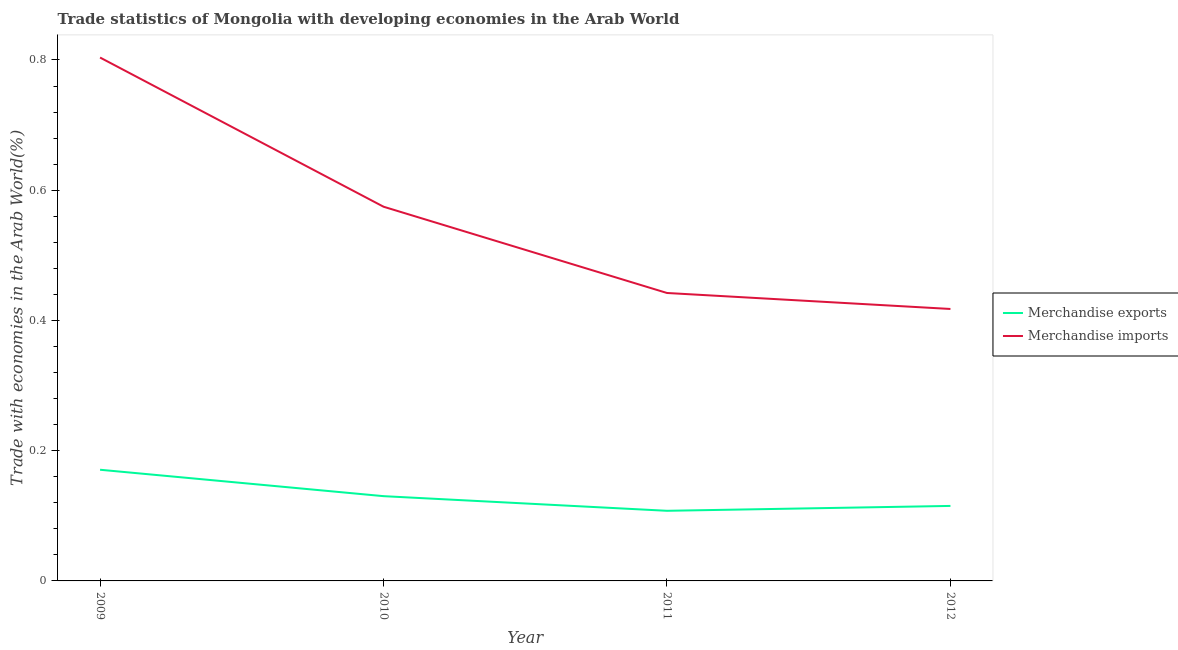Is the number of lines equal to the number of legend labels?
Your answer should be compact. Yes. What is the merchandise imports in 2009?
Your answer should be very brief. 0.8. Across all years, what is the maximum merchandise exports?
Give a very brief answer. 0.17. Across all years, what is the minimum merchandise imports?
Offer a terse response. 0.42. In which year was the merchandise exports maximum?
Your answer should be compact. 2009. In which year was the merchandise exports minimum?
Give a very brief answer. 2011. What is the total merchandise imports in the graph?
Your answer should be very brief. 2.24. What is the difference between the merchandise exports in 2009 and that in 2012?
Give a very brief answer. 0.06. What is the difference between the merchandise exports in 2012 and the merchandise imports in 2011?
Provide a succinct answer. -0.33. What is the average merchandise exports per year?
Your answer should be compact. 0.13. In the year 2011, what is the difference between the merchandise exports and merchandise imports?
Your response must be concise. -0.33. What is the ratio of the merchandise imports in 2011 to that in 2012?
Offer a very short reply. 1.06. Is the merchandise exports in 2011 less than that in 2012?
Offer a very short reply. Yes. Is the difference between the merchandise imports in 2009 and 2011 greater than the difference between the merchandise exports in 2009 and 2011?
Your response must be concise. Yes. What is the difference between the highest and the second highest merchandise imports?
Offer a very short reply. 0.23. What is the difference between the highest and the lowest merchandise imports?
Provide a succinct answer. 0.39. Is the sum of the merchandise exports in 2009 and 2010 greater than the maximum merchandise imports across all years?
Offer a terse response. No. Does the merchandise exports monotonically increase over the years?
Provide a short and direct response. No. How many years are there in the graph?
Keep it short and to the point. 4. Are the values on the major ticks of Y-axis written in scientific E-notation?
Provide a succinct answer. No. Does the graph contain any zero values?
Offer a very short reply. No. Does the graph contain grids?
Give a very brief answer. No. How many legend labels are there?
Make the answer very short. 2. What is the title of the graph?
Your answer should be compact. Trade statistics of Mongolia with developing economies in the Arab World. Does "Study and work" appear as one of the legend labels in the graph?
Offer a terse response. No. What is the label or title of the Y-axis?
Your answer should be very brief. Trade with economies in the Arab World(%). What is the Trade with economies in the Arab World(%) of Merchandise exports in 2009?
Provide a short and direct response. 0.17. What is the Trade with economies in the Arab World(%) of Merchandise imports in 2009?
Your answer should be very brief. 0.8. What is the Trade with economies in the Arab World(%) of Merchandise exports in 2010?
Ensure brevity in your answer.  0.13. What is the Trade with economies in the Arab World(%) of Merchandise imports in 2010?
Make the answer very short. 0.57. What is the Trade with economies in the Arab World(%) of Merchandise exports in 2011?
Ensure brevity in your answer.  0.11. What is the Trade with economies in the Arab World(%) of Merchandise imports in 2011?
Provide a succinct answer. 0.44. What is the Trade with economies in the Arab World(%) of Merchandise exports in 2012?
Your answer should be compact. 0.12. What is the Trade with economies in the Arab World(%) of Merchandise imports in 2012?
Offer a terse response. 0.42. Across all years, what is the maximum Trade with economies in the Arab World(%) in Merchandise exports?
Offer a very short reply. 0.17. Across all years, what is the maximum Trade with economies in the Arab World(%) in Merchandise imports?
Your answer should be compact. 0.8. Across all years, what is the minimum Trade with economies in the Arab World(%) of Merchandise exports?
Ensure brevity in your answer.  0.11. Across all years, what is the minimum Trade with economies in the Arab World(%) of Merchandise imports?
Provide a succinct answer. 0.42. What is the total Trade with economies in the Arab World(%) of Merchandise exports in the graph?
Offer a very short reply. 0.52. What is the total Trade with economies in the Arab World(%) in Merchandise imports in the graph?
Ensure brevity in your answer.  2.24. What is the difference between the Trade with economies in the Arab World(%) of Merchandise exports in 2009 and that in 2010?
Offer a very short reply. 0.04. What is the difference between the Trade with economies in the Arab World(%) of Merchandise imports in 2009 and that in 2010?
Your answer should be very brief. 0.23. What is the difference between the Trade with economies in the Arab World(%) in Merchandise exports in 2009 and that in 2011?
Provide a short and direct response. 0.06. What is the difference between the Trade with economies in the Arab World(%) of Merchandise imports in 2009 and that in 2011?
Provide a short and direct response. 0.36. What is the difference between the Trade with economies in the Arab World(%) in Merchandise exports in 2009 and that in 2012?
Provide a succinct answer. 0.06. What is the difference between the Trade with economies in the Arab World(%) in Merchandise imports in 2009 and that in 2012?
Offer a terse response. 0.39. What is the difference between the Trade with economies in the Arab World(%) of Merchandise exports in 2010 and that in 2011?
Give a very brief answer. 0.02. What is the difference between the Trade with economies in the Arab World(%) in Merchandise imports in 2010 and that in 2011?
Provide a succinct answer. 0.13. What is the difference between the Trade with economies in the Arab World(%) of Merchandise exports in 2010 and that in 2012?
Your answer should be compact. 0.01. What is the difference between the Trade with economies in the Arab World(%) in Merchandise imports in 2010 and that in 2012?
Offer a very short reply. 0.16. What is the difference between the Trade with economies in the Arab World(%) in Merchandise exports in 2011 and that in 2012?
Provide a succinct answer. -0.01. What is the difference between the Trade with economies in the Arab World(%) of Merchandise imports in 2011 and that in 2012?
Your response must be concise. 0.02. What is the difference between the Trade with economies in the Arab World(%) of Merchandise exports in 2009 and the Trade with economies in the Arab World(%) of Merchandise imports in 2010?
Give a very brief answer. -0.4. What is the difference between the Trade with economies in the Arab World(%) in Merchandise exports in 2009 and the Trade with economies in the Arab World(%) in Merchandise imports in 2011?
Make the answer very short. -0.27. What is the difference between the Trade with economies in the Arab World(%) of Merchandise exports in 2009 and the Trade with economies in the Arab World(%) of Merchandise imports in 2012?
Keep it short and to the point. -0.25. What is the difference between the Trade with economies in the Arab World(%) in Merchandise exports in 2010 and the Trade with economies in the Arab World(%) in Merchandise imports in 2011?
Offer a very short reply. -0.31. What is the difference between the Trade with economies in the Arab World(%) in Merchandise exports in 2010 and the Trade with economies in the Arab World(%) in Merchandise imports in 2012?
Offer a terse response. -0.29. What is the difference between the Trade with economies in the Arab World(%) in Merchandise exports in 2011 and the Trade with economies in the Arab World(%) in Merchandise imports in 2012?
Your response must be concise. -0.31. What is the average Trade with economies in the Arab World(%) of Merchandise exports per year?
Offer a terse response. 0.13. What is the average Trade with economies in the Arab World(%) of Merchandise imports per year?
Your response must be concise. 0.56. In the year 2009, what is the difference between the Trade with economies in the Arab World(%) of Merchandise exports and Trade with economies in the Arab World(%) of Merchandise imports?
Provide a short and direct response. -0.63. In the year 2010, what is the difference between the Trade with economies in the Arab World(%) of Merchandise exports and Trade with economies in the Arab World(%) of Merchandise imports?
Offer a terse response. -0.44. In the year 2011, what is the difference between the Trade with economies in the Arab World(%) of Merchandise exports and Trade with economies in the Arab World(%) of Merchandise imports?
Give a very brief answer. -0.33. In the year 2012, what is the difference between the Trade with economies in the Arab World(%) of Merchandise exports and Trade with economies in the Arab World(%) of Merchandise imports?
Offer a very short reply. -0.3. What is the ratio of the Trade with economies in the Arab World(%) of Merchandise exports in 2009 to that in 2010?
Your response must be concise. 1.31. What is the ratio of the Trade with economies in the Arab World(%) of Merchandise imports in 2009 to that in 2010?
Give a very brief answer. 1.4. What is the ratio of the Trade with economies in the Arab World(%) of Merchandise exports in 2009 to that in 2011?
Ensure brevity in your answer.  1.59. What is the ratio of the Trade with economies in the Arab World(%) of Merchandise imports in 2009 to that in 2011?
Provide a short and direct response. 1.82. What is the ratio of the Trade with economies in the Arab World(%) of Merchandise exports in 2009 to that in 2012?
Keep it short and to the point. 1.48. What is the ratio of the Trade with economies in the Arab World(%) of Merchandise imports in 2009 to that in 2012?
Your answer should be very brief. 1.92. What is the ratio of the Trade with economies in the Arab World(%) of Merchandise exports in 2010 to that in 2011?
Offer a very short reply. 1.21. What is the ratio of the Trade with economies in the Arab World(%) of Merchandise imports in 2010 to that in 2011?
Your answer should be very brief. 1.3. What is the ratio of the Trade with economies in the Arab World(%) in Merchandise exports in 2010 to that in 2012?
Make the answer very short. 1.13. What is the ratio of the Trade with economies in the Arab World(%) of Merchandise imports in 2010 to that in 2012?
Make the answer very short. 1.38. What is the ratio of the Trade with economies in the Arab World(%) in Merchandise exports in 2011 to that in 2012?
Keep it short and to the point. 0.94. What is the ratio of the Trade with economies in the Arab World(%) of Merchandise imports in 2011 to that in 2012?
Offer a terse response. 1.06. What is the difference between the highest and the second highest Trade with economies in the Arab World(%) of Merchandise exports?
Provide a succinct answer. 0.04. What is the difference between the highest and the second highest Trade with economies in the Arab World(%) of Merchandise imports?
Your response must be concise. 0.23. What is the difference between the highest and the lowest Trade with economies in the Arab World(%) of Merchandise exports?
Keep it short and to the point. 0.06. What is the difference between the highest and the lowest Trade with economies in the Arab World(%) of Merchandise imports?
Your response must be concise. 0.39. 